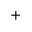Convert formula to latex. <formula><loc_0><loc_0><loc_500><loc_500>+</formula> 